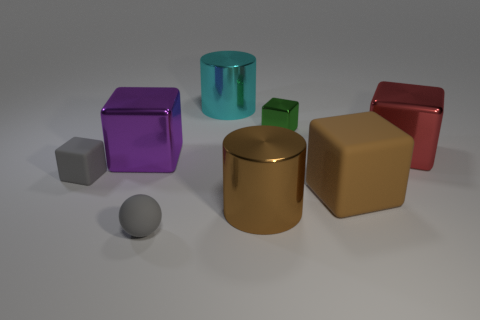Subtract all purple cubes. How many cubes are left? 4 Subtract all purple shiny cubes. How many cubes are left? 4 Subtract all cyan blocks. Subtract all blue spheres. How many blocks are left? 5 Add 1 green cubes. How many objects exist? 9 Subtract all cylinders. How many objects are left? 6 Subtract 0 blue cubes. How many objects are left? 8 Subtract all small green objects. Subtract all big metal cubes. How many objects are left? 5 Add 5 matte spheres. How many matte spheres are left? 6 Add 7 metallic cylinders. How many metallic cylinders exist? 9 